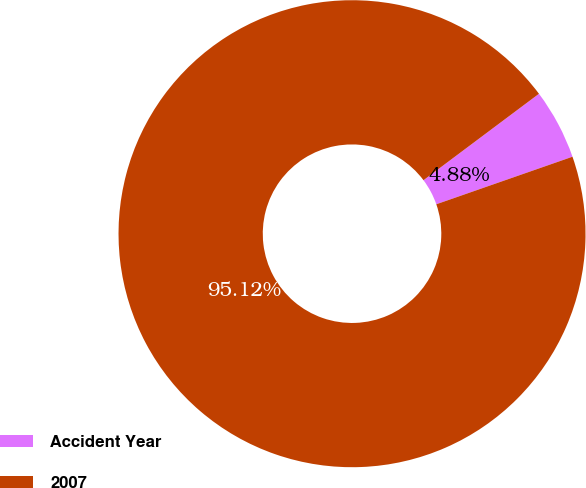Convert chart to OTSL. <chart><loc_0><loc_0><loc_500><loc_500><pie_chart><fcel>Accident Year<fcel>2007<nl><fcel>4.88%<fcel>95.12%<nl></chart> 